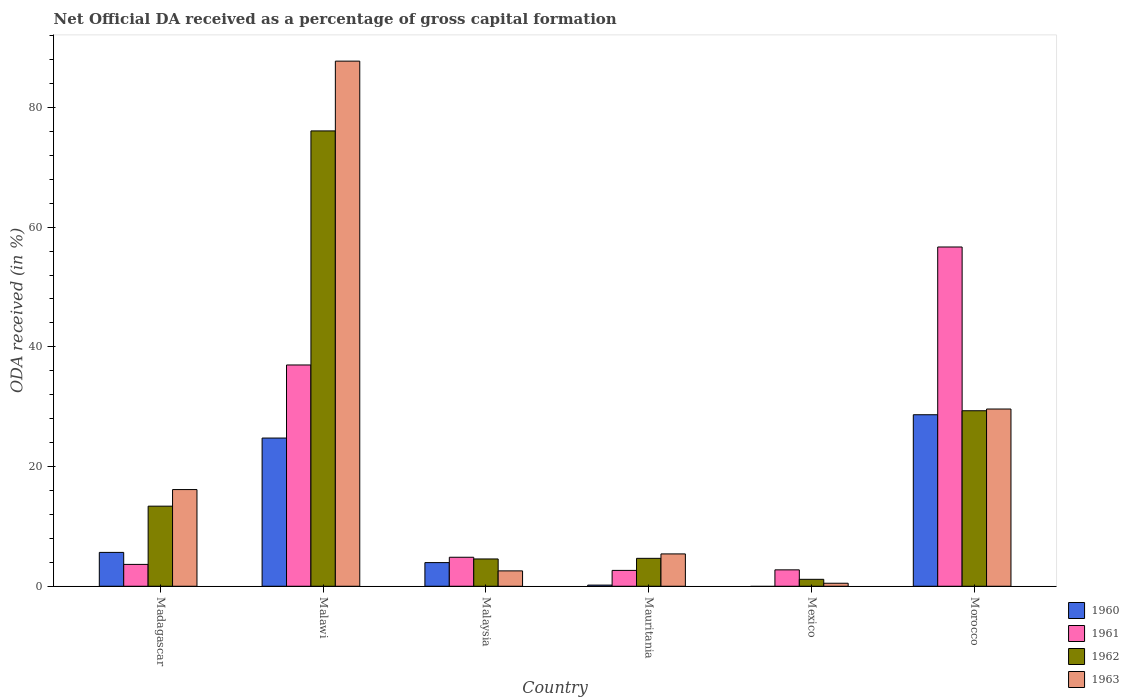How many bars are there on the 2nd tick from the left?
Offer a very short reply. 4. How many bars are there on the 2nd tick from the right?
Give a very brief answer. 3. What is the label of the 1st group of bars from the left?
Your response must be concise. Madagascar. In how many cases, is the number of bars for a given country not equal to the number of legend labels?
Offer a terse response. 1. What is the net ODA received in 1960 in Mexico?
Ensure brevity in your answer.  0. Across all countries, what is the maximum net ODA received in 1962?
Provide a succinct answer. 76.08. Across all countries, what is the minimum net ODA received in 1963?
Your response must be concise. 0.5. In which country was the net ODA received in 1963 maximum?
Your answer should be very brief. Malawi. What is the total net ODA received in 1962 in the graph?
Ensure brevity in your answer.  129.17. What is the difference between the net ODA received in 1962 in Madagascar and that in Morocco?
Keep it short and to the point. -15.94. What is the difference between the net ODA received in 1961 in Malawi and the net ODA received in 1963 in Morocco?
Offer a very short reply. 7.36. What is the average net ODA received in 1963 per country?
Ensure brevity in your answer.  23.66. What is the difference between the net ODA received of/in 1960 and net ODA received of/in 1962 in Malawi?
Your answer should be compact. -51.32. What is the ratio of the net ODA received in 1961 in Malaysia to that in Mauritania?
Your answer should be compact. 1.83. Is the net ODA received in 1960 in Madagascar less than that in Mauritania?
Give a very brief answer. No. What is the difference between the highest and the second highest net ODA received in 1961?
Ensure brevity in your answer.  19.71. What is the difference between the highest and the lowest net ODA received in 1962?
Offer a very short reply. 74.92. In how many countries, is the net ODA received in 1963 greater than the average net ODA received in 1963 taken over all countries?
Provide a succinct answer. 2. Is the sum of the net ODA received in 1961 in Mauritania and Morocco greater than the maximum net ODA received in 1963 across all countries?
Keep it short and to the point. No. Is it the case that in every country, the sum of the net ODA received in 1961 and net ODA received in 1960 is greater than the sum of net ODA received in 1963 and net ODA received in 1962?
Ensure brevity in your answer.  No. Is it the case that in every country, the sum of the net ODA received in 1960 and net ODA received in 1963 is greater than the net ODA received in 1961?
Your answer should be very brief. No. Are all the bars in the graph horizontal?
Provide a short and direct response. No. How are the legend labels stacked?
Offer a terse response. Vertical. What is the title of the graph?
Offer a terse response. Net Official DA received as a percentage of gross capital formation. Does "1991" appear as one of the legend labels in the graph?
Give a very brief answer. No. What is the label or title of the Y-axis?
Your response must be concise. ODA received (in %). What is the ODA received (in %) of 1960 in Madagascar?
Give a very brief answer. 5.66. What is the ODA received (in %) in 1961 in Madagascar?
Provide a short and direct response. 3.65. What is the ODA received (in %) in 1962 in Madagascar?
Ensure brevity in your answer.  13.38. What is the ODA received (in %) of 1963 in Madagascar?
Make the answer very short. 16.15. What is the ODA received (in %) of 1960 in Malawi?
Your answer should be compact. 24.76. What is the ODA received (in %) of 1961 in Malawi?
Your answer should be compact. 36.97. What is the ODA received (in %) of 1962 in Malawi?
Make the answer very short. 76.08. What is the ODA received (in %) in 1963 in Malawi?
Make the answer very short. 87.74. What is the ODA received (in %) of 1960 in Malaysia?
Offer a terse response. 3.95. What is the ODA received (in %) of 1961 in Malaysia?
Your answer should be compact. 4.84. What is the ODA received (in %) in 1962 in Malaysia?
Offer a terse response. 4.56. What is the ODA received (in %) of 1963 in Malaysia?
Your answer should be very brief. 2.57. What is the ODA received (in %) in 1960 in Mauritania?
Provide a succinct answer. 0.19. What is the ODA received (in %) in 1961 in Mauritania?
Provide a succinct answer. 2.65. What is the ODA received (in %) in 1962 in Mauritania?
Your answer should be compact. 4.66. What is the ODA received (in %) in 1963 in Mauritania?
Give a very brief answer. 5.4. What is the ODA received (in %) in 1961 in Mexico?
Offer a terse response. 2.74. What is the ODA received (in %) in 1962 in Mexico?
Offer a very short reply. 1.16. What is the ODA received (in %) in 1963 in Mexico?
Your answer should be compact. 0.5. What is the ODA received (in %) in 1960 in Morocco?
Keep it short and to the point. 28.66. What is the ODA received (in %) in 1961 in Morocco?
Your response must be concise. 56.69. What is the ODA received (in %) of 1962 in Morocco?
Your answer should be compact. 29.32. What is the ODA received (in %) in 1963 in Morocco?
Make the answer very short. 29.61. Across all countries, what is the maximum ODA received (in %) in 1960?
Provide a short and direct response. 28.66. Across all countries, what is the maximum ODA received (in %) of 1961?
Your answer should be compact. 56.69. Across all countries, what is the maximum ODA received (in %) in 1962?
Make the answer very short. 76.08. Across all countries, what is the maximum ODA received (in %) of 1963?
Give a very brief answer. 87.74. Across all countries, what is the minimum ODA received (in %) in 1960?
Provide a succinct answer. 0. Across all countries, what is the minimum ODA received (in %) of 1961?
Ensure brevity in your answer.  2.65. Across all countries, what is the minimum ODA received (in %) of 1962?
Provide a succinct answer. 1.16. Across all countries, what is the minimum ODA received (in %) in 1963?
Your response must be concise. 0.5. What is the total ODA received (in %) in 1960 in the graph?
Provide a succinct answer. 63.22. What is the total ODA received (in %) in 1961 in the graph?
Give a very brief answer. 107.54. What is the total ODA received (in %) of 1962 in the graph?
Your answer should be compact. 129.17. What is the total ODA received (in %) in 1963 in the graph?
Provide a short and direct response. 141.98. What is the difference between the ODA received (in %) in 1960 in Madagascar and that in Malawi?
Offer a terse response. -19.11. What is the difference between the ODA received (in %) in 1961 in Madagascar and that in Malawi?
Provide a short and direct response. -33.32. What is the difference between the ODA received (in %) in 1962 in Madagascar and that in Malawi?
Ensure brevity in your answer.  -62.7. What is the difference between the ODA received (in %) of 1963 in Madagascar and that in Malawi?
Your answer should be very brief. -71.59. What is the difference between the ODA received (in %) in 1960 in Madagascar and that in Malaysia?
Your response must be concise. 1.7. What is the difference between the ODA received (in %) in 1961 in Madagascar and that in Malaysia?
Keep it short and to the point. -1.19. What is the difference between the ODA received (in %) of 1962 in Madagascar and that in Malaysia?
Your response must be concise. 8.82. What is the difference between the ODA received (in %) of 1963 in Madagascar and that in Malaysia?
Provide a short and direct response. 13.59. What is the difference between the ODA received (in %) in 1960 in Madagascar and that in Mauritania?
Your response must be concise. 5.46. What is the difference between the ODA received (in %) in 1961 in Madagascar and that in Mauritania?
Ensure brevity in your answer.  1. What is the difference between the ODA received (in %) of 1962 in Madagascar and that in Mauritania?
Offer a terse response. 8.72. What is the difference between the ODA received (in %) in 1963 in Madagascar and that in Mauritania?
Keep it short and to the point. 10.75. What is the difference between the ODA received (in %) of 1962 in Madagascar and that in Mexico?
Ensure brevity in your answer.  12.22. What is the difference between the ODA received (in %) of 1963 in Madagascar and that in Mexico?
Keep it short and to the point. 15.65. What is the difference between the ODA received (in %) of 1960 in Madagascar and that in Morocco?
Provide a succinct answer. -23. What is the difference between the ODA received (in %) of 1961 in Madagascar and that in Morocco?
Give a very brief answer. -53.03. What is the difference between the ODA received (in %) of 1962 in Madagascar and that in Morocco?
Provide a short and direct response. -15.94. What is the difference between the ODA received (in %) of 1963 in Madagascar and that in Morocco?
Provide a short and direct response. -13.46. What is the difference between the ODA received (in %) in 1960 in Malawi and that in Malaysia?
Offer a very short reply. 20.81. What is the difference between the ODA received (in %) in 1961 in Malawi and that in Malaysia?
Offer a terse response. 32.13. What is the difference between the ODA received (in %) in 1962 in Malawi and that in Malaysia?
Give a very brief answer. 71.52. What is the difference between the ODA received (in %) of 1963 in Malawi and that in Malaysia?
Make the answer very short. 85.17. What is the difference between the ODA received (in %) in 1960 in Malawi and that in Mauritania?
Your answer should be compact. 24.57. What is the difference between the ODA received (in %) of 1961 in Malawi and that in Mauritania?
Offer a terse response. 34.32. What is the difference between the ODA received (in %) of 1962 in Malawi and that in Mauritania?
Your answer should be very brief. 71.42. What is the difference between the ODA received (in %) in 1963 in Malawi and that in Mauritania?
Provide a short and direct response. 82.34. What is the difference between the ODA received (in %) of 1961 in Malawi and that in Mexico?
Provide a succinct answer. 34.23. What is the difference between the ODA received (in %) in 1962 in Malawi and that in Mexico?
Your response must be concise. 74.92. What is the difference between the ODA received (in %) of 1963 in Malawi and that in Mexico?
Provide a short and direct response. 87.24. What is the difference between the ODA received (in %) in 1960 in Malawi and that in Morocco?
Give a very brief answer. -3.9. What is the difference between the ODA received (in %) in 1961 in Malawi and that in Morocco?
Ensure brevity in your answer.  -19.71. What is the difference between the ODA received (in %) of 1962 in Malawi and that in Morocco?
Provide a short and direct response. 46.76. What is the difference between the ODA received (in %) in 1963 in Malawi and that in Morocco?
Your response must be concise. 58.13. What is the difference between the ODA received (in %) in 1960 in Malaysia and that in Mauritania?
Make the answer very short. 3.76. What is the difference between the ODA received (in %) of 1961 in Malaysia and that in Mauritania?
Your answer should be compact. 2.2. What is the difference between the ODA received (in %) of 1962 in Malaysia and that in Mauritania?
Offer a terse response. -0.1. What is the difference between the ODA received (in %) of 1963 in Malaysia and that in Mauritania?
Your response must be concise. -2.83. What is the difference between the ODA received (in %) in 1961 in Malaysia and that in Mexico?
Make the answer very short. 2.11. What is the difference between the ODA received (in %) in 1962 in Malaysia and that in Mexico?
Keep it short and to the point. 3.4. What is the difference between the ODA received (in %) of 1963 in Malaysia and that in Mexico?
Offer a terse response. 2.07. What is the difference between the ODA received (in %) of 1960 in Malaysia and that in Morocco?
Give a very brief answer. -24.71. What is the difference between the ODA received (in %) in 1961 in Malaysia and that in Morocco?
Provide a succinct answer. -51.84. What is the difference between the ODA received (in %) in 1962 in Malaysia and that in Morocco?
Give a very brief answer. -24.76. What is the difference between the ODA received (in %) in 1963 in Malaysia and that in Morocco?
Offer a terse response. -27.04. What is the difference between the ODA received (in %) in 1961 in Mauritania and that in Mexico?
Offer a terse response. -0.09. What is the difference between the ODA received (in %) in 1962 in Mauritania and that in Mexico?
Provide a succinct answer. 3.51. What is the difference between the ODA received (in %) in 1963 in Mauritania and that in Mexico?
Offer a terse response. 4.9. What is the difference between the ODA received (in %) in 1960 in Mauritania and that in Morocco?
Make the answer very short. -28.47. What is the difference between the ODA received (in %) in 1961 in Mauritania and that in Morocco?
Provide a short and direct response. -54.04. What is the difference between the ODA received (in %) in 1962 in Mauritania and that in Morocco?
Ensure brevity in your answer.  -24.66. What is the difference between the ODA received (in %) of 1963 in Mauritania and that in Morocco?
Make the answer very short. -24.21. What is the difference between the ODA received (in %) of 1961 in Mexico and that in Morocco?
Keep it short and to the point. -53.95. What is the difference between the ODA received (in %) in 1962 in Mexico and that in Morocco?
Your answer should be compact. -28.17. What is the difference between the ODA received (in %) in 1963 in Mexico and that in Morocco?
Provide a short and direct response. -29.11. What is the difference between the ODA received (in %) in 1960 in Madagascar and the ODA received (in %) in 1961 in Malawi?
Offer a terse response. -31.32. What is the difference between the ODA received (in %) of 1960 in Madagascar and the ODA received (in %) of 1962 in Malawi?
Offer a very short reply. -70.43. What is the difference between the ODA received (in %) of 1960 in Madagascar and the ODA received (in %) of 1963 in Malawi?
Provide a succinct answer. -82.08. What is the difference between the ODA received (in %) of 1961 in Madagascar and the ODA received (in %) of 1962 in Malawi?
Your response must be concise. -72.43. What is the difference between the ODA received (in %) in 1961 in Madagascar and the ODA received (in %) in 1963 in Malawi?
Your answer should be very brief. -84.09. What is the difference between the ODA received (in %) of 1962 in Madagascar and the ODA received (in %) of 1963 in Malawi?
Provide a succinct answer. -74.36. What is the difference between the ODA received (in %) of 1960 in Madagascar and the ODA received (in %) of 1961 in Malaysia?
Make the answer very short. 0.81. What is the difference between the ODA received (in %) in 1960 in Madagascar and the ODA received (in %) in 1962 in Malaysia?
Your response must be concise. 1.09. What is the difference between the ODA received (in %) of 1960 in Madagascar and the ODA received (in %) of 1963 in Malaysia?
Offer a terse response. 3.09. What is the difference between the ODA received (in %) in 1961 in Madagascar and the ODA received (in %) in 1962 in Malaysia?
Offer a terse response. -0.91. What is the difference between the ODA received (in %) of 1961 in Madagascar and the ODA received (in %) of 1963 in Malaysia?
Ensure brevity in your answer.  1.08. What is the difference between the ODA received (in %) in 1962 in Madagascar and the ODA received (in %) in 1963 in Malaysia?
Offer a terse response. 10.81. What is the difference between the ODA received (in %) of 1960 in Madagascar and the ODA received (in %) of 1961 in Mauritania?
Offer a very short reply. 3.01. What is the difference between the ODA received (in %) in 1960 in Madagascar and the ODA received (in %) in 1963 in Mauritania?
Provide a succinct answer. 0.25. What is the difference between the ODA received (in %) of 1961 in Madagascar and the ODA received (in %) of 1962 in Mauritania?
Make the answer very short. -1.01. What is the difference between the ODA received (in %) in 1961 in Madagascar and the ODA received (in %) in 1963 in Mauritania?
Your answer should be very brief. -1.75. What is the difference between the ODA received (in %) in 1962 in Madagascar and the ODA received (in %) in 1963 in Mauritania?
Provide a succinct answer. 7.98. What is the difference between the ODA received (in %) of 1960 in Madagascar and the ODA received (in %) of 1961 in Mexico?
Offer a very short reply. 2.92. What is the difference between the ODA received (in %) of 1960 in Madagascar and the ODA received (in %) of 1962 in Mexico?
Your answer should be compact. 4.5. What is the difference between the ODA received (in %) in 1960 in Madagascar and the ODA received (in %) in 1963 in Mexico?
Keep it short and to the point. 5.15. What is the difference between the ODA received (in %) in 1961 in Madagascar and the ODA received (in %) in 1962 in Mexico?
Offer a terse response. 2.49. What is the difference between the ODA received (in %) in 1961 in Madagascar and the ODA received (in %) in 1963 in Mexico?
Offer a very short reply. 3.15. What is the difference between the ODA received (in %) in 1962 in Madagascar and the ODA received (in %) in 1963 in Mexico?
Keep it short and to the point. 12.88. What is the difference between the ODA received (in %) in 1960 in Madagascar and the ODA received (in %) in 1961 in Morocco?
Make the answer very short. -51.03. What is the difference between the ODA received (in %) of 1960 in Madagascar and the ODA received (in %) of 1962 in Morocco?
Offer a very short reply. -23.67. What is the difference between the ODA received (in %) in 1960 in Madagascar and the ODA received (in %) in 1963 in Morocco?
Your response must be concise. -23.96. What is the difference between the ODA received (in %) in 1961 in Madagascar and the ODA received (in %) in 1962 in Morocco?
Give a very brief answer. -25.67. What is the difference between the ODA received (in %) in 1961 in Madagascar and the ODA received (in %) in 1963 in Morocco?
Offer a very short reply. -25.96. What is the difference between the ODA received (in %) in 1962 in Madagascar and the ODA received (in %) in 1963 in Morocco?
Offer a very short reply. -16.23. What is the difference between the ODA received (in %) of 1960 in Malawi and the ODA received (in %) of 1961 in Malaysia?
Keep it short and to the point. 19.92. What is the difference between the ODA received (in %) in 1960 in Malawi and the ODA received (in %) in 1962 in Malaysia?
Provide a short and direct response. 20.2. What is the difference between the ODA received (in %) in 1960 in Malawi and the ODA received (in %) in 1963 in Malaysia?
Offer a very short reply. 22.19. What is the difference between the ODA received (in %) in 1961 in Malawi and the ODA received (in %) in 1962 in Malaysia?
Give a very brief answer. 32.41. What is the difference between the ODA received (in %) in 1961 in Malawi and the ODA received (in %) in 1963 in Malaysia?
Provide a succinct answer. 34.4. What is the difference between the ODA received (in %) in 1962 in Malawi and the ODA received (in %) in 1963 in Malaysia?
Provide a short and direct response. 73.51. What is the difference between the ODA received (in %) of 1960 in Malawi and the ODA received (in %) of 1961 in Mauritania?
Ensure brevity in your answer.  22.11. What is the difference between the ODA received (in %) in 1960 in Malawi and the ODA received (in %) in 1962 in Mauritania?
Offer a very short reply. 20.1. What is the difference between the ODA received (in %) of 1960 in Malawi and the ODA received (in %) of 1963 in Mauritania?
Ensure brevity in your answer.  19.36. What is the difference between the ODA received (in %) in 1961 in Malawi and the ODA received (in %) in 1962 in Mauritania?
Offer a very short reply. 32.31. What is the difference between the ODA received (in %) of 1961 in Malawi and the ODA received (in %) of 1963 in Mauritania?
Keep it short and to the point. 31.57. What is the difference between the ODA received (in %) in 1962 in Malawi and the ODA received (in %) in 1963 in Mauritania?
Your answer should be compact. 70.68. What is the difference between the ODA received (in %) in 1960 in Malawi and the ODA received (in %) in 1961 in Mexico?
Your response must be concise. 22.02. What is the difference between the ODA received (in %) of 1960 in Malawi and the ODA received (in %) of 1962 in Mexico?
Make the answer very short. 23.6. What is the difference between the ODA received (in %) in 1960 in Malawi and the ODA received (in %) in 1963 in Mexico?
Offer a terse response. 24.26. What is the difference between the ODA received (in %) of 1961 in Malawi and the ODA received (in %) of 1962 in Mexico?
Your response must be concise. 35.82. What is the difference between the ODA received (in %) of 1961 in Malawi and the ODA received (in %) of 1963 in Mexico?
Your answer should be very brief. 36.47. What is the difference between the ODA received (in %) in 1962 in Malawi and the ODA received (in %) in 1963 in Mexico?
Offer a terse response. 75.58. What is the difference between the ODA received (in %) of 1960 in Malawi and the ODA received (in %) of 1961 in Morocco?
Keep it short and to the point. -31.92. What is the difference between the ODA received (in %) of 1960 in Malawi and the ODA received (in %) of 1962 in Morocco?
Provide a succinct answer. -4.56. What is the difference between the ODA received (in %) of 1960 in Malawi and the ODA received (in %) of 1963 in Morocco?
Offer a very short reply. -4.85. What is the difference between the ODA received (in %) in 1961 in Malawi and the ODA received (in %) in 1962 in Morocco?
Provide a short and direct response. 7.65. What is the difference between the ODA received (in %) of 1961 in Malawi and the ODA received (in %) of 1963 in Morocco?
Keep it short and to the point. 7.36. What is the difference between the ODA received (in %) of 1962 in Malawi and the ODA received (in %) of 1963 in Morocco?
Make the answer very short. 46.47. What is the difference between the ODA received (in %) of 1960 in Malaysia and the ODA received (in %) of 1961 in Mauritania?
Keep it short and to the point. 1.3. What is the difference between the ODA received (in %) of 1960 in Malaysia and the ODA received (in %) of 1962 in Mauritania?
Your response must be concise. -0.71. What is the difference between the ODA received (in %) of 1960 in Malaysia and the ODA received (in %) of 1963 in Mauritania?
Your answer should be very brief. -1.45. What is the difference between the ODA received (in %) of 1961 in Malaysia and the ODA received (in %) of 1962 in Mauritania?
Provide a succinct answer. 0.18. What is the difference between the ODA received (in %) in 1961 in Malaysia and the ODA received (in %) in 1963 in Mauritania?
Provide a succinct answer. -0.56. What is the difference between the ODA received (in %) of 1962 in Malaysia and the ODA received (in %) of 1963 in Mauritania?
Keep it short and to the point. -0.84. What is the difference between the ODA received (in %) in 1960 in Malaysia and the ODA received (in %) in 1961 in Mexico?
Provide a succinct answer. 1.21. What is the difference between the ODA received (in %) of 1960 in Malaysia and the ODA received (in %) of 1962 in Mexico?
Provide a short and direct response. 2.79. What is the difference between the ODA received (in %) in 1960 in Malaysia and the ODA received (in %) in 1963 in Mexico?
Make the answer very short. 3.45. What is the difference between the ODA received (in %) of 1961 in Malaysia and the ODA received (in %) of 1962 in Mexico?
Keep it short and to the point. 3.69. What is the difference between the ODA received (in %) of 1961 in Malaysia and the ODA received (in %) of 1963 in Mexico?
Keep it short and to the point. 4.34. What is the difference between the ODA received (in %) in 1962 in Malaysia and the ODA received (in %) in 1963 in Mexico?
Your answer should be compact. 4.06. What is the difference between the ODA received (in %) in 1960 in Malaysia and the ODA received (in %) in 1961 in Morocco?
Ensure brevity in your answer.  -52.73. What is the difference between the ODA received (in %) of 1960 in Malaysia and the ODA received (in %) of 1962 in Morocco?
Make the answer very short. -25.37. What is the difference between the ODA received (in %) in 1960 in Malaysia and the ODA received (in %) in 1963 in Morocco?
Provide a succinct answer. -25.66. What is the difference between the ODA received (in %) of 1961 in Malaysia and the ODA received (in %) of 1962 in Morocco?
Give a very brief answer. -24.48. What is the difference between the ODA received (in %) of 1961 in Malaysia and the ODA received (in %) of 1963 in Morocco?
Offer a terse response. -24.77. What is the difference between the ODA received (in %) of 1962 in Malaysia and the ODA received (in %) of 1963 in Morocco?
Ensure brevity in your answer.  -25.05. What is the difference between the ODA received (in %) in 1960 in Mauritania and the ODA received (in %) in 1961 in Mexico?
Offer a terse response. -2.55. What is the difference between the ODA received (in %) in 1960 in Mauritania and the ODA received (in %) in 1962 in Mexico?
Make the answer very short. -0.97. What is the difference between the ODA received (in %) of 1960 in Mauritania and the ODA received (in %) of 1963 in Mexico?
Provide a short and direct response. -0.31. What is the difference between the ODA received (in %) in 1961 in Mauritania and the ODA received (in %) in 1962 in Mexico?
Give a very brief answer. 1.49. What is the difference between the ODA received (in %) in 1961 in Mauritania and the ODA received (in %) in 1963 in Mexico?
Make the answer very short. 2.15. What is the difference between the ODA received (in %) of 1962 in Mauritania and the ODA received (in %) of 1963 in Mexico?
Ensure brevity in your answer.  4.16. What is the difference between the ODA received (in %) in 1960 in Mauritania and the ODA received (in %) in 1961 in Morocco?
Your answer should be very brief. -56.49. What is the difference between the ODA received (in %) of 1960 in Mauritania and the ODA received (in %) of 1962 in Morocco?
Make the answer very short. -29.13. What is the difference between the ODA received (in %) of 1960 in Mauritania and the ODA received (in %) of 1963 in Morocco?
Your answer should be compact. -29.42. What is the difference between the ODA received (in %) of 1961 in Mauritania and the ODA received (in %) of 1962 in Morocco?
Ensure brevity in your answer.  -26.68. What is the difference between the ODA received (in %) of 1961 in Mauritania and the ODA received (in %) of 1963 in Morocco?
Ensure brevity in your answer.  -26.96. What is the difference between the ODA received (in %) of 1962 in Mauritania and the ODA received (in %) of 1963 in Morocco?
Make the answer very short. -24.95. What is the difference between the ODA received (in %) in 1961 in Mexico and the ODA received (in %) in 1962 in Morocco?
Your answer should be very brief. -26.59. What is the difference between the ODA received (in %) in 1961 in Mexico and the ODA received (in %) in 1963 in Morocco?
Ensure brevity in your answer.  -26.87. What is the difference between the ODA received (in %) of 1962 in Mexico and the ODA received (in %) of 1963 in Morocco?
Offer a terse response. -28.46. What is the average ODA received (in %) of 1960 per country?
Provide a succinct answer. 10.54. What is the average ODA received (in %) in 1961 per country?
Offer a very short reply. 17.92. What is the average ODA received (in %) of 1962 per country?
Give a very brief answer. 21.53. What is the average ODA received (in %) of 1963 per country?
Keep it short and to the point. 23.66. What is the difference between the ODA received (in %) of 1960 and ODA received (in %) of 1961 in Madagascar?
Provide a short and direct response. 2. What is the difference between the ODA received (in %) in 1960 and ODA received (in %) in 1962 in Madagascar?
Offer a very short reply. -7.72. What is the difference between the ODA received (in %) in 1960 and ODA received (in %) in 1963 in Madagascar?
Offer a very short reply. -10.5. What is the difference between the ODA received (in %) in 1961 and ODA received (in %) in 1962 in Madagascar?
Make the answer very short. -9.73. What is the difference between the ODA received (in %) in 1961 and ODA received (in %) in 1963 in Madagascar?
Provide a succinct answer. -12.5. What is the difference between the ODA received (in %) in 1962 and ODA received (in %) in 1963 in Madagascar?
Ensure brevity in your answer.  -2.77. What is the difference between the ODA received (in %) in 1960 and ODA received (in %) in 1961 in Malawi?
Provide a succinct answer. -12.21. What is the difference between the ODA received (in %) of 1960 and ODA received (in %) of 1962 in Malawi?
Offer a terse response. -51.32. What is the difference between the ODA received (in %) of 1960 and ODA received (in %) of 1963 in Malawi?
Keep it short and to the point. -62.98. What is the difference between the ODA received (in %) in 1961 and ODA received (in %) in 1962 in Malawi?
Your response must be concise. -39.11. What is the difference between the ODA received (in %) of 1961 and ODA received (in %) of 1963 in Malawi?
Offer a very short reply. -50.77. What is the difference between the ODA received (in %) in 1962 and ODA received (in %) in 1963 in Malawi?
Offer a terse response. -11.66. What is the difference between the ODA received (in %) in 1960 and ODA received (in %) in 1961 in Malaysia?
Your response must be concise. -0.89. What is the difference between the ODA received (in %) in 1960 and ODA received (in %) in 1962 in Malaysia?
Your answer should be compact. -0.61. What is the difference between the ODA received (in %) of 1960 and ODA received (in %) of 1963 in Malaysia?
Your answer should be very brief. 1.38. What is the difference between the ODA received (in %) of 1961 and ODA received (in %) of 1962 in Malaysia?
Keep it short and to the point. 0.28. What is the difference between the ODA received (in %) of 1961 and ODA received (in %) of 1963 in Malaysia?
Provide a succinct answer. 2.28. What is the difference between the ODA received (in %) of 1962 and ODA received (in %) of 1963 in Malaysia?
Offer a very short reply. 1.99. What is the difference between the ODA received (in %) in 1960 and ODA received (in %) in 1961 in Mauritania?
Offer a very short reply. -2.46. What is the difference between the ODA received (in %) in 1960 and ODA received (in %) in 1962 in Mauritania?
Offer a terse response. -4.47. What is the difference between the ODA received (in %) in 1960 and ODA received (in %) in 1963 in Mauritania?
Give a very brief answer. -5.21. What is the difference between the ODA received (in %) in 1961 and ODA received (in %) in 1962 in Mauritania?
Make the answer very short. -2.02. What is the difference between the ODA received (in %) of 1961 and ODA received (in %) of 1963 in Mauritania?
Your answer should be very brief. -2.75. What is the difference between the ODA received (in %) of 1962 and ODA received (in %) of 1963 in Mauritania?
Give a very brief answer. -0.74. What is the difference between the ODA received (in %) in 1961 and ODA received (in %) in 1962 in Mexico?
Provide a succinct answer. 1.58. What is the difference between the ODA received (in %) in 1961 and ODA received (in %) in 1963 in Mexico?
Provide a short and direct response. 2.24. What is the difference between the ODA received (in %) of 1962 and ODA received (in %) of 1963 in Mexico?
Keep it short and to the point. 0.66. What is the difference between the ODA received (in %) of 1960 and ODA received (in %) of 1961 in Morocco?
Give a very brief answer. -28.03. What is the difference between the ODA received (in %) of 1960 and ODA received (in %) of 1962 in Morocco?
Your answer should be compact. -0.67. What is the difference between the ODA received (in %) in 1960 and ODA received (in %) in 1963 in Morocco?
Provide a succinct answer. -0.96. What is the difference between the ODA received (in %) of 1961 and ODA received (in %) of 1962 in Morocco?
Make the answer very short. 27.36. What is the difference between the ODA received (in %) of 1961 and ODA received (in %) of 1963 in Morocco?
Make the answer very short. 27.07. What is the difference between the ODA received (in %) of 1962 and ODA received (in %) of 1963 in Morocco?
Give a very brief answer. -0.29. What is the ratio of the ODA received (in %) in 1960 in Madagascar to that in Malawi?
Your response must be concise. 0.23. What is the ratio of the ODA received (in %) in 1961 in Madagascar to that in Malawi?
Offer a terse response. 0.1. What is the ratio of the ODA received (in %) in 1962 in Madagascar to that in Malawi?
Provide a short and direct response. 0.18. What is the ratio of the ODA received (in %) in 1963 in Madagascar to that in Malawi?
Give a very brief answer. 0.18. What is the ratio of the ODA received (in %) in 1960 in Madagascar to that in Malaysia?
Offer a terse response. 1.43. What is the ratio of the ODA received (in %) in 1961 in Madagascar to that in Malaysia?
Offer a terse response. 0.75. What is the ratio of the ODA received (in %) of 1962 in Madagascar to that in Malaysia?
Provide a succinct answer. 2.93. What is the ratio of the ODA received (in %) of 1963 in Madagascar to that in Malaysia?
Offer a terse response. 6.29. What is the ratio of the ODA received (in %) of 1960 in Madagascar to that in Mauritania?
Your answer should be very brief. 29.63. What is the ratio of the ODA received (in %) in 1961 in Madagascar to that in Mauritania?
Give a very brief answer. 1.38. What is the ratio of the ODA received (in %) of 1962 in Madagascar to that in Mauritania?
Provide a succinct answer. 2.87. What is the ratio of the ODA received (in %) of 1963 in Madagascar to that in Mauritania?
Your answer should be compact. 2.99. What is the ratio of the ODA received (in %) of 1961 in Madagascar to that in Mexico?
Offer a terse response. 1.33. What is the ratio of the ODA received (in %) in 1962 in Madagascar to that in Mexico?
Give a very brief answer. 11.56. What is the ratio of the ODA received (in %) of 1963 in Madagascar to that in Mexico?
Your answer should be very brief. 32.21. What is the ratio of the ODA received (in %) of 1960 in Madagascar to that in Morocco?
Offer a very short reply. 0.2. What is the ratio of the ODA received (in %) of 1961 in Madagascar to that in Morocco?
Provide a succinct answer. 0.06. What is the ratio of the ODA received (in %) in 1962 in Madagascar to that in Morocco?
Make the answer very short. 0.46. What is the ratio of the ODA received (in %) of 1963 in Madagascar to that in Morocco?
Offer a very short reply. 0.55. What is the ratio of the ODA received (in %) in 1960 in Malawi to that in Malaysia?
Your answer should be very brief. 6.27. What is the ratio of the ODA received (in %) of 1961 in Malawi to that in Malaysia?
Give a very brief answer. 7.63. What is the ratio of the ODA received (in %) in 1962 in Malawi to that in Malaysia?
Your response must be concise. 16.68. What is the ratio of the ODA received (in %) in 1963 in Malawi to that in Malaysia?
Ensure brevity in your answer.  34.15. What is the ratio of the ODA received (in %) of 1960 in Malawi to that in Mauritania?
Give a very brief answer. 129.73. What is the ratio of the ODA received (in %) of 1961 in Malawi to that in Mauritania?
Your response must be concise. 13.96. What is the ratio of the ODA received (in %) in 1962 in Malawi to that in Mauritania?
Offer a very short reply. 16.31. What is the ratio of the ODA received (in %) of 1963 in Malawi to that in Mauritania?
Provide a short and direct response. 16.24. What is the ratio of the ODA received (in %) in 1961 in Malawi to that in Mexico?
Provide a short and direct response. 13.5. What is the ratio of the ODA received (in %) of 1962 in Malawi to that in Mexico?
Offer a terse response. 65.75. What is the ratio of the ODA received (in %) in 1963 in Malawi to that in Mexico?
Ensure brevity in your answer.  174.93. What is the ratio of the ODA received (in %) in 1960 in Malawi to that in Morocco?
Provide a short and direct response. 0.86. What is the ratio of the ODA received (in %) of 1961 in Malawi to that in Morocco?
Offer a very short reply. 0.65. What is the ratio of the ODA received (in %) of 1962 in Malawi to that in Morocco?
Provide a short and direct response. 2.59. What is the ratio of the ODA received (in %) of 1963 in Malawi to that in Morocco?
Keep it short and to the point. 2.96. What is the ratio of the ODA received (in %) of 1960 in Malaysia to that in Mauritania?
Give a very brief answer. 20.7. What is the ratio of the ODA received (in %) of 1961 in Malaysia to that in Mauritania?
Provide a succinct answer. 1.83. What is the ratio of the ODA received (in %) of 1962 in Malaysia to that in Mauritania?
Give a very brief answer. 0.98. What is the ratio of the ODA received (in %) in 1963 in Malaysia to that in Mauritania?
Your answer should be compact. 0.48. What is the ratio of the ODA received (in %) in 1961 in Malaysia to that in Mexico?
Make the answer very short. 1.77. What is the ratio of the ODA received (in %) in 1962 in Malaysia to that in Mexico?
Your answer should be compact. 3.94. What is the ratio of the ODA received (in %) of 1963 in Malaysia to that in Mexico?
Ensure brevity in your answer.  5.12. What is the ratio of the ODA received (in %) of 1960 in Malaysia to that in Morocco?
Offer a very short reply. 0.14. What is the ratio of the ODA received (in %) of 1961 in Malaysia to that in Morocco?
Your answer should be compact. 0.09. What is the ratio of the ODA received (in %) in 1962 in Malaysia to that in Morocco?
Offer a terse response. 0.16. What is the ratio of the ODA received (in %) of 1963 in Malaysia to that in Morocco?
Offer a terse response. 0.09. What is the ratio of the ODA received (in %) of 1961 in Mauritania to that in Mexico?
Your answer should be compact. 0.97. What is the ratio of the ODA received (in %) of 1962 in Mauritania to that in Mexico?
Provide a succinct answer. 4.03. What is the ratio of the ODA received (in %) in 1963 in Mauritania to that in Mexico?
Keep it short and to the point. 10.77. What is the ratio of the ODA received (in %) in 1960 in Mauritania to that in Morocco?
Ensure brevity in your answer.  0.01. What is the ratio of the ODA received (in %) of 1961 in Mauritania to that in Morocco?
Offer a terse response. 0.05. What is the ratio of the ODA received (in %) in 1962 in Mauritania to that in Morocco?
Your answer should be very brief. 0.16. What is the ratio of the ODA received (in %) in 1963 in Mauritania to that in Morocco?
Give a very brief answer. 0.18. What is the ratio of the ODA received (in %) in 1961 in Mexico to that in Morocco?
Ensure brevity in your answer.  0.05. What is the ratio of the ODA received (in %) of 1962 in Mexico to that in Morocco?
Make the answer very short. 0.04. What is the ratio of the ODA received (in %) in 1963 in Mexico to that in Morocco?
Ensure brevity in your answer.  0.02. What is the difference between the highest and the second highest ODA received (in %) of 1960?
Make the answer very short. 3.9. What is the difference between the highest and the second highest ODA received (in %) in 1961?
Offer a terse response. 19.71. What is the difference between the highest and the second highest ODA received (in %) of 1962?
Your answer should be compact. 46.76. What is the difference between the highest and the second highest ODA received (in %) of 1963?
Give a very brief answer. 58.13. What is the difference between the highest and the lowest ODA received (in %) in 1960?
Your answer should be compact. 28.66. What is the difference between the highest and the lowest ODA received (in %) of 1961?
Give a very brief answer. 54.04. What is the difference between the highest and the lowest ODA received (in %) in 1962?
Provide a short and direct response. 74.92. What is the difference between the highest and the lowest ODA received (in %) of 1963?
Your response must be concise. 87.24. 